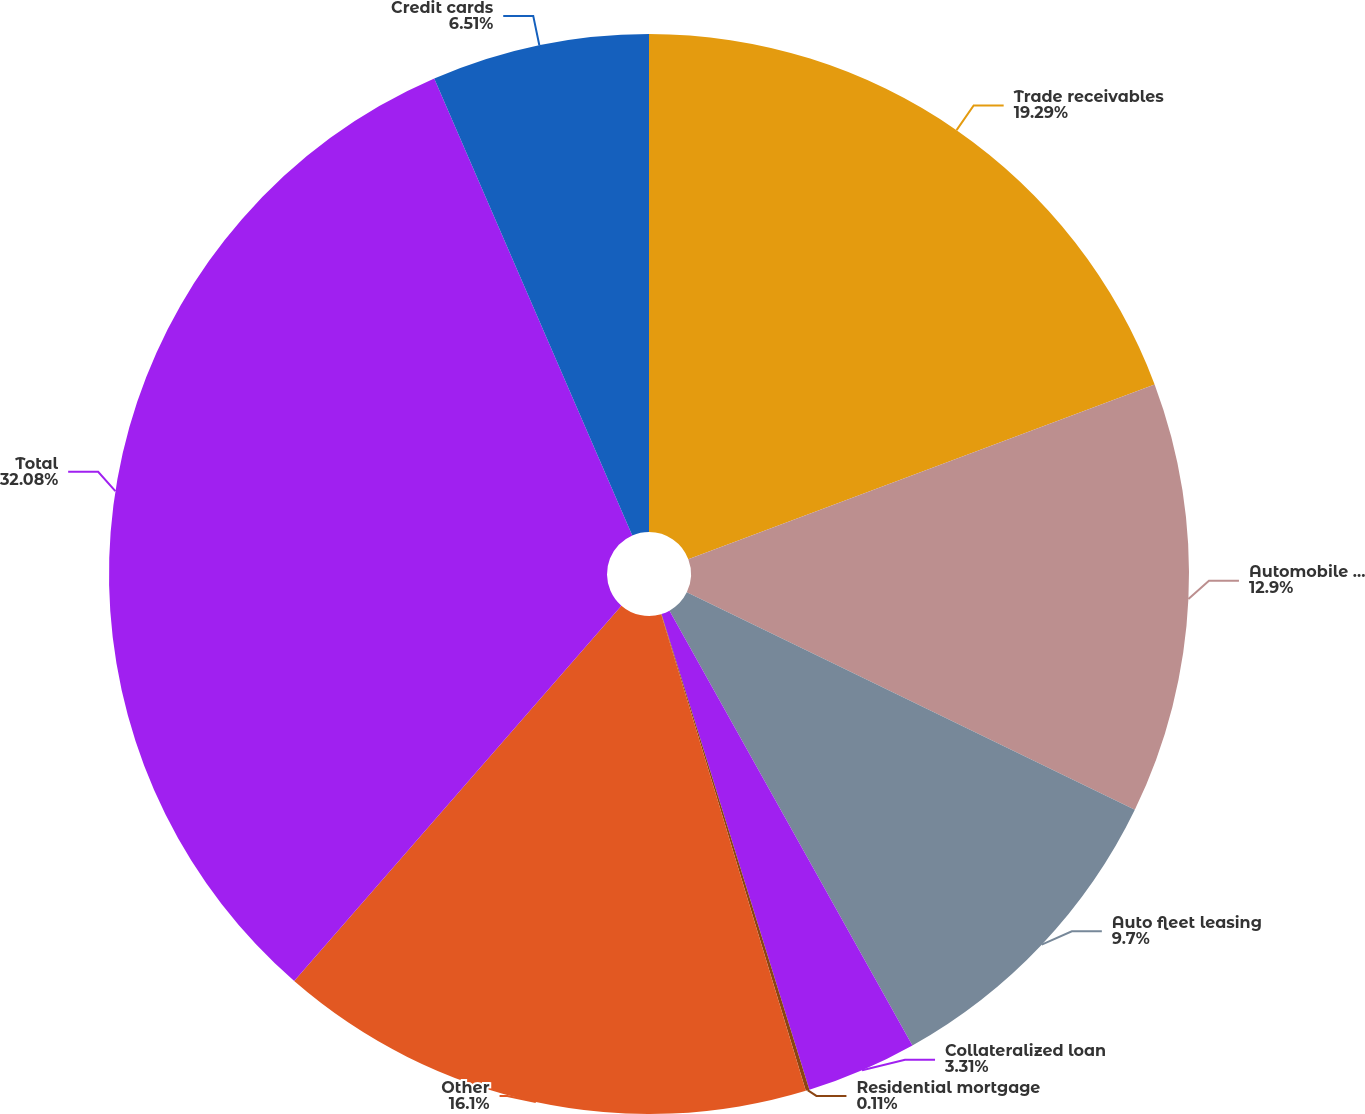<chart> <loc_0><loc_0><loc_500><loc_500><pie_chart><fcel>Trade receivables<fcel>Automobile financing<fcel>Auto fleet leasing<fcel>Collateralized loan<fcel>Residential mortgage<fcel>Other<fcel>Total<fcel>Credit cards<nl><fcel>19.29%<fcel>12.9%<fcel>9.7%<fcel>3.31%<fcel>0.11%<fcel>16.1%<fcel>32.08%<fcel>6.51%<nl></chart> 